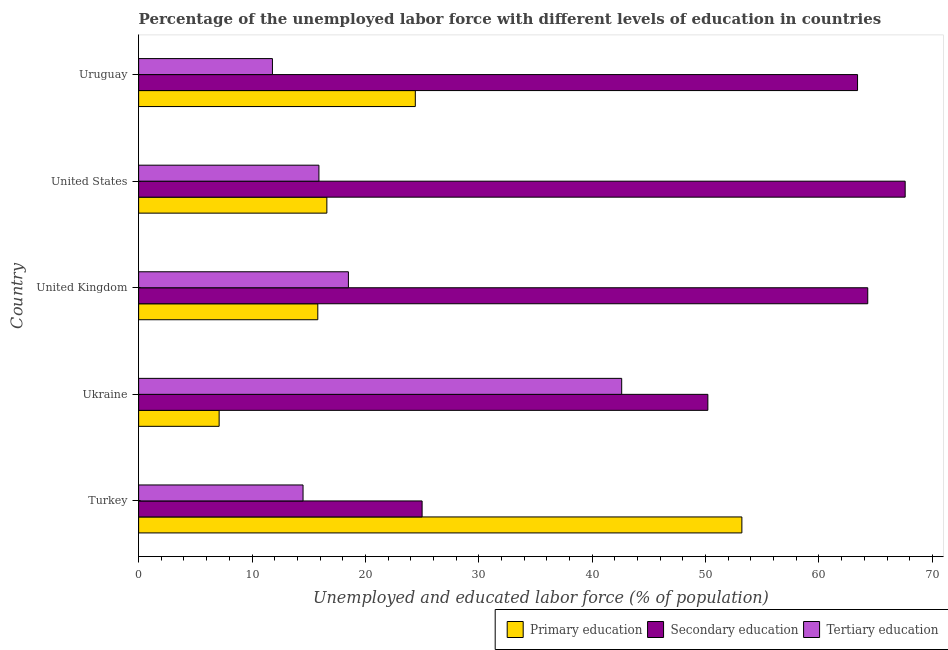How many different coloured bars are there?
Your answer should be compact. 3. Are the number of bars per tick equal to the number of legend labels?
Offer a very short reply. Yes. Are the number of bars on each tick of the Y-axis equal?
Your answer should be very brief. Yes. What is the percentage of labor force who received primary education in Ukraine?
Give a very brief answer. 7.1. Across all countries, what is the maximum percentage of labor force who received secondary education?
Give a very brief answer. 67.6. Across all countries, what is the minimum percentage of labor force who received secondary education?
Your response must be concise. 25. In which country was the percentage of labor force who received tertiary education maximum?
Make the answer very short. Ukraine. In which country was the percentage of labor force who received secondary education minimum?
Give a very brief answer. Turkey. What is the total percentage of labor force who received secondary education in the graph?
Your answer should be compact. 270.5. What is the difference between the percentage of labor force who received primary education in Ukraine and that in United Kingdom?
Ensure brevity in your answer.  -8.7. What is the difference between the percentage of labor force who received primary education in United Kingdom and the percentage of labor force who received secondary education in Uruguay?
Provide a short and direct response. -47.6. What is the average percentage of labor force who received tertiary education per country?
Your answer should be compact. 20.66. What is the ratio of the percentage of labor force who received primary education in United States to that in Uruguay?
Your answer should be compact. 0.68. What is the difference between the highest and the second highest percentage of labor force who received tertiary education?
Your answer should be very brief. 24.1. What is the difference between the highest and the lowest percentage of labor force who received secondary education?
Your answer should be very brief. 42.6. Is the sum of the percentage of labor force who received secondary education in Ukraine and United Kingdom greater than the maximum percentage of labor force who received tertiary education across all countries?
Ensure brevity in your answer.  Yes. What does the 1st bar from the top in United States represents?
Make the answer very short. Tertiary education. What does the 3rd bar from the bottom in Turkey represents?
Your response must be concise. Tertiary education. Does the graph contain any zero values?
Keep it short and to the point. No. Where does the legend appear in the graph?
Provide a succinct answer. Bottom right. How are the legend labels stacked?
Your answer should be very brief. Horizontal. What is the title of the graph?
Keep it short and to the point. Percentage of the unemployed labor force with different levels of education in countries. What is the label or title of the X-axis?
Ensure brevity in your answer.  Unemployed and educated labor force (% of population). What is the Unemployed and educated labor force (% of population) of Primary education in Turkey?
Your answer should be very brief. 53.2. What is the Unemployed and educated labor force (% of population) of Secondary education in Turkey?
Offer a terse response. 25. What is the Unemployed and educated labor force (% of population) in Tertiary education in Turkey?
Keep it short and to the point. 14.5. What is the Unemployed and educated labor force (% of population) of Primary education in Ukraine?
Your answer should be very brief. 7.1. What is the Unemployed and educated labor force (% of population) in Secondary education in Ukraine?
Your answer should be very brief. 50.2. What is the Unemployed and educated labor force (% of population) of Tertiary education in Ukraine?
Ensure brevity in your answer.  42.6. What is the Unemployed and educated labor force (% of population) of Primary education in United Kingdom?
Provide a succinct answer. 15.8. What is the Unemployed and educated labor force (% of population) of Secondary education in United Kingdom?
Provide a succinct answer. 64.3. What is the Unemployed and educated labor force (% of population) in Primary education in United States?
Offer a terse response. 16.6. What is the Unemployed and educated labor force (% of population) in Secondary education in United States?
Make the answer very short. 67.6. What is the Unemployed and educated labor force (% of population) in Tertiary education in United States?
Offer a terse response. 15.9. What is the Unemployed and educated labor force (% of population) in Primary education in Uruguay?
Provide a succinct answer. 24.4. What is the Unemployed and educated labor force (% of population) of Secondary education in Uruguay?
Provide a short and direct response. 63.4. What is the Unemployed and educated labor force (% of population) of Tertiary education in Uruguay?
Offer a very short reply. 11.8. Across all countries, what is the maximum Unemployed and educated labor force (% of population) in Primary education?
Your answer should be very brief. 53.2. Across all countries, what is the maximum Unemployed and educated labor force (% of population) in Secondary education?
Give a very brief answer. 67.6. Across all countries, what is the maximum Unemployed and educated labor force (% of population) in Tertiary education?
Ensure brevity in your answer.  42.6. Across all countries, what is the minimum Unemployed and educated labor force (% of population) in Primary education?
Ensure brevity in your answer.  7.1. Across all countries, what is the minimum Unemployed and educated labor force (% of population) of Secondary education?
Give a very brief answer. 25. Across all countries, what is the minimum Unemployed and educated labor force (% of population) in Tertiary education?
Your response must be concise. 11.8. What is the total Unemployed and educated labor force (% of population) in Primary education in the graph?
Offer a very short reply. 117.1. What is the total Unemployed and educated labor force (% of population) of Secondary education in the graph?
Offer a very short reply. 270.5. What is the total Unemployed and educated labor force (% of population) in Tertiary education in the graph?
Make the answer very short. 103.3. What is the difference between the Unemployed and educated labor force (% of population) in Primary education in Turkey and that in Ukraine?
Make the answer very short. 46.1. What is the difference between the Unemployed and educated labor force (% of population) in Secondary education in Turkey and that in Ukraine?
Offer a terse response. -25.2. What is the difference between the Unemployed and educated labor force (% of population) in Tertiary education in Turkey and that in Ukraine?
Make the answer very short. -28.1. What is the difference between the Unemployed and educated labor force (% of population) of Primary education in Turkey and that in United Kingdom?
Keep it short and to the point. 37.4. What is the difference between the Unemployed and educated labor force (% of population) of Secondary education in Turkey and that in United Kingdom?
Your response must be concise. -39.3. What is the difference between the Unemployed and educated labor force (% of population) of Tertiary education in Turkey and that in United Kingdom?
Make the answer very short. -4. What is the difference between the Unemployed and educated labor force (% of population) of Primary education in Turkey and that in United States?
Make the answer very short. 36.6. What is the difference between the Unemployed and educated labor force (% of population) in Secondary education in Turkey and that in United States?
Your answer should be compact. -42.6. What is the difference between the Unemployed and educated labor force (% of population) in Tertiary education in Turkey and that in United States?
Offer a very short reply. -1.4. What is the difference between the Unemployed and educated labor force (% of population) of Primary education in Turkey and that in Uruguay?
Your answer should be very brief. 28.8. What is the difference between the Unemployed and educated labor force (% of population) of Secondary education in Turkey and that in Uruguay?
Ensure brevity in your answer.  -38.4. What is the difference between the Unemployed and educated labor force (% of population) of Secondary education in Ukraine and that in United Kingdom?
Provide a succinct answer. -14.1. What is the difference between the Unemployed and educated labor force (% of population) in Tertiary education in Ukraine and that in United Kingdom?
Your response must be concise. 24.1. What is the difference between the Unemployed and educated labor force (% of population) of Secondary education in Ukraine and that in United States?
Your response must be concise. -17.4. What is the difference between the Unemployed and educated labor force (% of population) in Tertiary education in Ukraine and that in United States?
Your answer should be very brief. 26.7. What is the difference between the Unemployed and educated labor force (% of population) in Primary education in Ukraine and that in Uruguay?
Give a very brief answer. -17.3. What is the difference between the Unemployed and educated labor force (% of population) of Secondary education in Ukraine and that in Uruguay?
Your response must be concise. -13.2. What is the difference between the Unemployed and educated labor force (% of population) in Tertiary education in Ukraine and that in Uruguay?
Your answer should be very brief. 30.8. What is the difference between the Unemployed and educated labor force (% of population) in Secondary education in United Kingdom and that in United States?
Keep it short and to the point. -3.3. What is the difference between the Unemployed and educated labor force (% of population) in Secondary education in United Kingdom and that in Uruguay?
Offer a terse response. 0.9. What is the difference between the Unemployed and educated labor force (% of population) in Tertiary education in United Kingdom and that in Uruguay?
Ensure brevity in your answer.  6.7. What is the difference between the Unemployed and educated labor force (% of population) of Secondary education in United States and that in Uruguay?
Ensure brevity in your answer.  4.2. What is the difference between the Unemployed and educated labor force (% of population) in Primary education in Turkey and the Unemployed and educated labor force (% of population) in Tertiary education in Ukraine?
Provide a short and direct response. 10.6. What is the difference between the Unemployed and educated labor force (% of population) of Secondary education in Turkey and the Unemployed and educated labor force (% of population) of Tertiary education in Ukraine?
Offer a very short reply. -17.6. What is the difference between the Unemployed and educated labor force (% of population) in Primary education in Turkey and the Unemployed and educated labor force (% of population) in Tertiary education in United Kingdom?
Your answer should be very brief. 34.7. What is the difference between the Unemployed and educated labor force (% of population) in Secondary education in Turkey and the Unemployed and educated labor force (% of population) in Tertiary education in United Kingdom?
Your answer should be compact. 6.5. What is the difference between the Unemployed and educated labor force (% of population) of Primary education in Turkey and the Unemployed and educated labor force (% of population) of Secondary education in United States?
Give a very brief answer. -14.4. What is the difference between the Unemployed and educated labor force (% of population) in Primary education in Turkey and the Unemployed and educated labor force (% of population) in Tertiary education in United States?
Your answer should be compact. 37.3. What is the difference between the Unemployed and educated labor force (% of population) in Secondary education in Turkey and the Unemployed and educated labor force (% of population) in Tertiary education in United States?
Provide a succinct answer. 9.1. What is the difference between the Unemployed and educated labor force (% of population) of Primary education in Turkey and the Unemployed and educated labor force (% of population) of Secondary education in Uruguay?
Provide a succinct answer. -10.2. What is the difference between the Unemployed and educated labor force (% of population) in Primary education in Turkey and the Unemployed and educated labor force (% of population) in Tertiary education in Uruguay?
Ensure brevity in your answer.  41.4. What is the difference between the Unemployed and educated labor force (% of population) in Primary education in Ukraine and the Unemployed and educated labor force (% of population) in Secondary education in United Kingdom?
Your answer should be compact. -57.2. What is the difference between the Unemployed and educated labor force (% of population) of Secondary education in Ukraine and the Unemployed and educated labor force (% of population) of Tertiary education in United Kingdom?
Your answer should be very brief. 31.7. What is the difference between the Unemployed and educated labor force (% of population) in Primary education in Ukraine and the Unemployed and educated labor force (% of population) in Secondary education in United States?
Keep it short and to the point. -60.5. What is the difference between the Unemployed and educated labor force (% of population) in Secondary education in Ukraine and the Unemployed and educated labor force (% of population) in Tertiary education in United States?
Ensure brevity in your answer.  34.3. What is the difference between the Unemployed and educated labor force (% of population) in Primary education in Ukraine and the Unemployed and educated labor force (% of population) in Secondary education in Uruguay?
Provide a succinct answer. -56.3. What is the difference between the Unemployed and educated labor force (% of population) of Primary education in Ukraine and the Unemployed and educated labor force (% of population) of Tertiary education in Uruguay?
Make the answer very short. -4.7. What is the difference between the Unemployed and educated labor force (% of population) in Secondary education in Ukraine and the Unemployed and educated labor force (% of population) in Tertiary education in Uruguay?
Your answer should be very brief. 38.4. What is the difference between the Unemployed and educated labor force (% of population) of Primary education in United Kingdom and the Unemployed and educated labor force (% of population) of Secondary education in United States?
Your answer should be very brief. -51.8. What is the difference between the Unemployed and educated labor force (% of population) of Secondary education in United Kingdom and the Unemployed and educated labor force (% of population) of Tertiary education in United States?
Provide a short and direct response. 48.4. What is the difference between the Unemployed and educated labor force (% of population) of Primary education in United Kingdom and the Unemployed and educated labor force (% of population) of Secondary education in Uruguay?
Keep it short and to the point. -47.6. What is the difference between the Unemployed and educated labor force (% of population) in Secondary education in United Kingdom and the Unemployed and educated labor force (% of population) in Tertiary education in Uruguay?
Offer a very short reply. 52.5. What is the difference between the Unemployed and educated labor force (% of population) of Primary education in United States and the Unemployed and educated labor force (% of population) of Secondary education in Uruguay?
Your answer should be compact. -46.8. What is the difference between the Unemployed and educated labor force (% of population) of Primary education in United States and the Unemployed and educated labor force (% of population) of Tertiary education in Uruguay?
Your answer should be very brief. 4.8. What is the difference between the Unemployed and educated labor force (% of population) of Secondary education in United States and the Unemployed and educated labor force (% of population) of Tertiary education in Uruguay?
Provide a succinct answer. 55.8. What is the average Unemployed and educated labor force (% of population) in Primary education per country?
Your response must be concise. 23.42. What is the average Unemployed and educated labor force (% of population) in Secondary education per country?
Provide a succinct answer. 54.1. What is the average Unemployed and educated labor force (% of population) of Tertiary education per country?
Your answer should be very brief. 20.66. What is the difference between the Unemployed and educated labor force (% of population) of Primary education and Unemployed and educated labor force (% of population) of Secondary education in Turkey?
Provide a short and direct response. 28.2. What is the difference between the Unemployed and educated labor force (% of population) in Primary education and Unemployed and educated labor force (% of population) in Tertiary education in Turkey?
Provide a short and direct response. 38.7. What is the difference between the Unemployed and educated labor force (% of population) in Secondary education and Unemployed and educated labor force (% of population) in Tertiary education in Turkey?
Your answer should be very brief. 10.5. What is the difference between the Unemployed and educated labor force (% of population) of Primary education and Unemployed and educated labor force (% of population) of Secondary education in Ukraine?
Your response must be concise. -43.1. What is the difference between the Unemployed and educated labor force (% of population) in Primary education and Unemployed and educated labor force (% of population) in Tertiary education in Ukraine?
Make the answer very short. -35.5. What is the difference between the Unemployed and educated labor force (% of population) in Secondary education and Unemployed and educated labor force (% of population) in Tertiary education in Ukraine?
Ensure brevity in your answer.  7.6. What is the difference between the Unemployed and educated labor force (% of population) in Primary education and Unemployed and educated labor force (% of population) in Secondary education in United Kingdom?
Give a very brief answer. -48.5. What is the difference between the Unemployed and educated labor force (% of population) in Primary education and Unemployed and educated labor force (% of population) in Tertiary education in United Kingdom?
Your answer should be compact. -2.7. What is the difference between the Unemployed and educated labor force (% of population) of Secondary education and Unemployed and educated labor force (% of population) of Tertiary education in United Kingdom?
Give a very brief answer. 45.8. What is the difference between the Unemployed and educated labor force (% of population) in Primary education and Unemployed and educated labor force (% of population) in Secondary education in United States?
Your answer should be very brief. -51. What is the difference between the Unemployed and educated labor force (% of population) in Secondary education and Unemployed and educated labor force (% of population) in Tertiary education in United States?
Ensure brevity in your answer.  51.7. What is the difference between the Unemployed and educated labor force (% of population) in Primary education and Unemployed and educated labor force (% of population) in Secondary education in Uruguay?
Your answer should be very brief. -39. What is the difference between the Unemployed and educated labor force (% of population) in Secondary education and Unemployed and educated labor force (% of population) in Tertiary education in Uruguay?
Ensure brevity in your answer.  51.6. What is the ratio of the Unemployed and educated labor force (% of population) in Primary education in Turkey to that in Ukraine?
Offer a very short reply. 7.49. What is the ratio of the Unemployed and educated labor force (% of population) of Secondary education in Turkey to that in Ukraine?
Your response must be concise. 0.5. What is the ratio of the Unemployed and educated labor force (% of population) of Tertiary education in Turkey to that in Ukraine?
Keep it short and to the point. 0.34. What is the ratio of the Unemployed and educated labor force (% of population) in Primary education in Turkey to that in United Kingdom?
Your response must be concise. 3.37. What is the ratio of the Unemployed and educated labor force (% of population) in Secondary education in Turkey to that in United Kingdom?
Provide a succinct answer. 0.39. What is the ratio of the Unemployed and educated labor force (% of population) in Tertiary education in Turkey to that in United Kingdom?
Provide a short and direct response. 0.78. What is the ratio of the Unemployed and educated labor force (% of population) in Primary education in Turkey to that in United States?
Your answer should be compact. 3.2. What is the ratio of the Unemployed and educated labor force (% of population) of Secondary education in Turkey to that in United States?
Your answer should be very brief. 0.37. What is the ratio of the Unemployed and educated labor force (% of population) of Tertiary education in Turkey to that in United States?
Make the answer very short. 0.91. What is the ratio of the Unemployed and educated labor force (% of population) of Primary education in Turkey to that in Uruguay?
Offer a terse response. 2.18. What is the ratio of the Unemployed and educated labor force (% of population) in Secondary education in Turkey to that in Uruguay?
Give a very brief answer. 0.39. What is the ratio of the Unemployed and educated labor force (% of population) in Tertiary education in Turkey to that in Uruguay?
Your answer should be compact. 1.23. What is the ratio of the Unemployed and educated labor force (% of population) in Primary education in Ukraine to that in United Kingdom?
Keep it short and to the point. 0.45. What is the ratio of the Unemployed and educated labor force (% of population) of Secondary education in Ukraine to that in United Kingdom?
Your answer should be very brief. 0.78. What is the ratio of the Unemployed and educated labor force (% of population) in Tertiary education in Ukraine to that in United Kingdom?
Offer a terse response. 2.3. What is the ratio of the Unemployed and educated labor force (% of population) of Primary education in Ukraine to that in United States?
Give a very brief answer. 0.43. What is the ratio of the Unemployed and educated labor force (% of population) of Secondary education in Ukraine to that in United States?
Provide a short and direct response. 0.74. What is the ratio of the Unemployed and educated labor force (% of population) of Tertiary education in Ukraine to that in United States?
Your answer should be compact. 2.68. What is the ratio of the Unemployed and educated labor force (% of population) of Primary education in Ukraine to that in Uruguay?
Ensure brevity in your answer.  0.29. What is the ratio of the Unemployed and educated labor force (% of population) of Secondary education in Ukraine to that in Uruguay?
Your response must be concise. 0.79. What is the ratio of the Unemployed and educated labor force (% of population) of Tertiary education in Ukraine to that in Uruguay?
Make the answer very short. 3.61. What is the ratio of the Unemployed and educated labor force (% of population) of Primary education in United Kingdom to that in United States?
Your answer should be very brief. 0.95. What is the ratio of the Unemployed and educated labor force (% of population) of Secondary education in United Kingdom to that in United States?
Your answer should be compact. 0.95. What is the ratio of the Unemployed and educated labor force (% of population) in Tertiary education in United Kingdom to that in United States?
Give a very brief answer. 1.16. What is the ratio of the Unemployed and educated labor force (% of population) in Primary education in United Kingdom to that in Uruguay?
Your response must be concise. 0.65. What is the ratio of the Unemployed and educated labor force (% of population) in Secondary education in United Kingdom to that in Uruguay?
Keep it short and to the point. 1.01. What is the ratio of the Unemployed and educated labor force (% of population) in Tertiary education in United Kingdom to that in Uruguay?
Offer a terse response. 1.57. What is the ratio of the Unemployed and educated labor force (% of population) of Primary education in United States to that in Uruguay?
Provide a short and direct response. 0.68. What is the ratio of the Unemployed and educated labor force (% of population) in Secondary education in United States to that in Uruguay?
Keep it short and to the point. 1.07. What is the ratio of the Unemployed and educated labor force (% of population) of Tertiary education in United States to that in Uruguay?
Your response must be concise. 1.35. What is the difference between the highest and the second highest Unemployed and educated labor force (% of population) in Primary education?
Provide a short and direct response. 28.8. What is the difference between the highest and the second highest Unemployed and educated labor force (% of population) of Tertiary education?
Your answer should be compact. 24.1. What is the difference between the highest and the lowest Unemployed and educated labor force (% of population) in Primary education?
Your answer should be compact. 46.1. What is the difference between the highest and the lowest Unemployed and educated labor force (% of population) of Secondary education?
Your response must be concise. 42.6. What is the difference between the highest and the lowest Unemployed and educated labor force (% of population) of Tertiary education?
Provide a succinct answer. 30.8. 